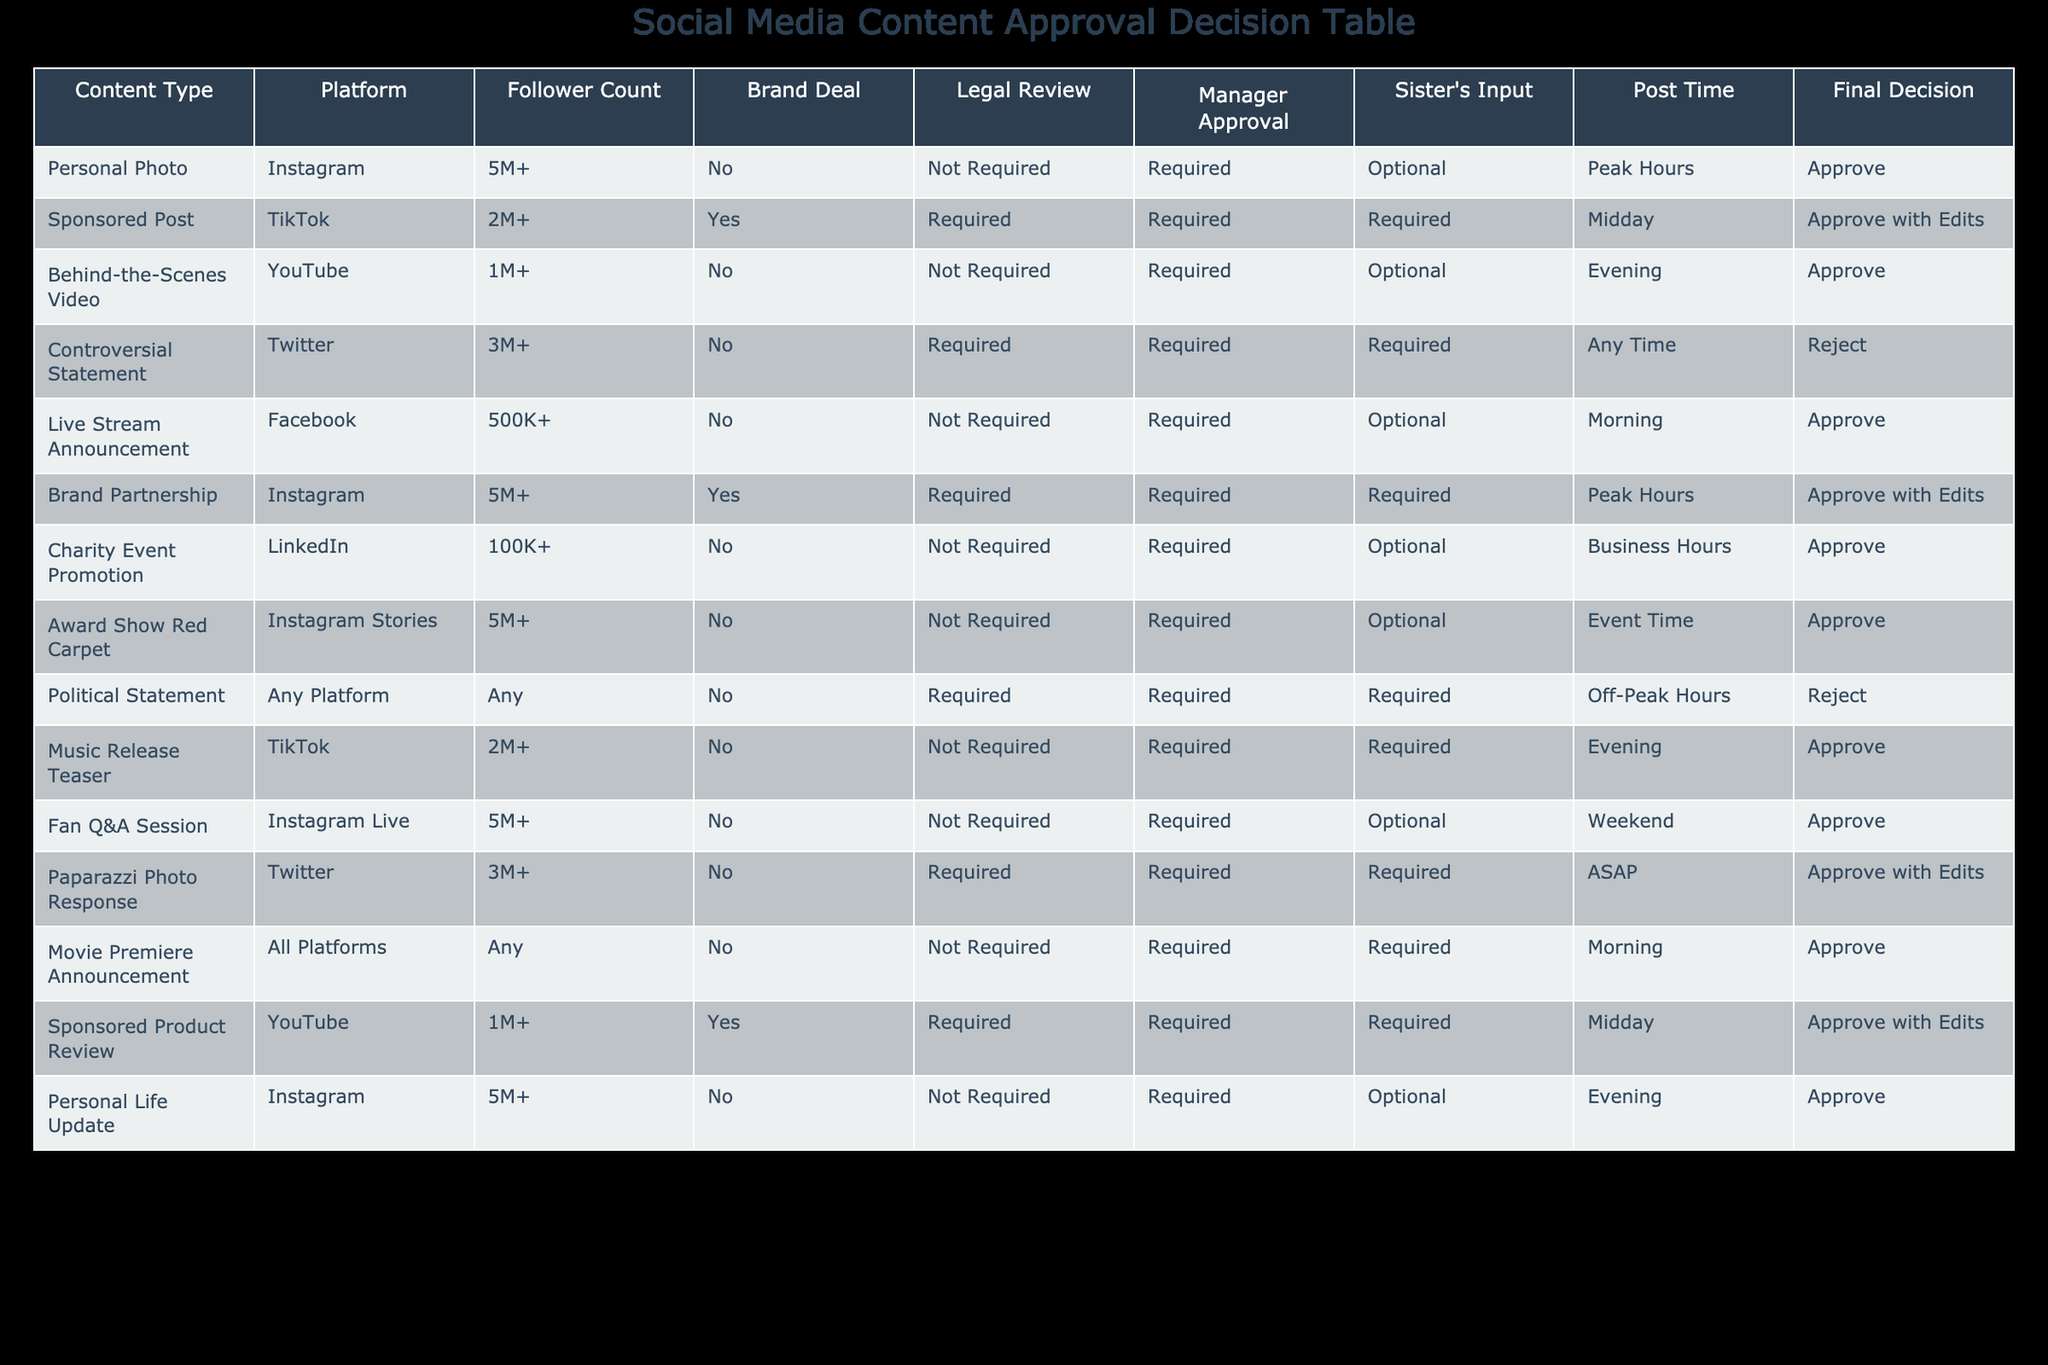What type of content requires legal review on TikTok? In the table, there are two entries for TikTok. The "Sponsored Post" has a "Legal Review" marked as "Required", while the "Music Release Teaser" does not require legal review. Thus, only the "Sponsored Post" requires legal review.
Answer: Sponsored Post How many content types received "Approve with Edits"? There are three entries with "Final Decision" listed as "Approve with Edits". They are "Sponsored Post", "Brand Partnership", and "Paparazzi Photo Response". So, the total is three.
Answer: 3 Is the "Charity Event Promotion" approved? The "Charity Event Promotion" entry shows a "Final Decision" of "Approve", meaning it was approved without any conditions.
Answer: Yes Which platform has the highest follower count for content requiring legal review? The table shows that the "Sponsored Product Review" on YouTube has a follower count of exactly "1M+". However, looking at the TikTok "Sponsored Post," it has "2M+" followers, making it the highest follower count for posts requiring legal review.
Answer: TikTok What percentage of the posts are approved without requests for edits or conditions? In the table, there are 12 types of content. Out of these, 6 received straightforward "Approve" decisions without edits or conditions: "Personal Photo," "Behind-the-Scenes Video," "Live Stream Announcement," "Award Show Red Carpet," "Fan Q&A Session," and "Personal Life Update." The percentage is (6/12) * 100 = 50%.
Answer: 50% How many rejected posts required both legal review and manager approval? In the table, the only post that was rejected is the "Controversial Statement," which required both "Legal Review" and "Manager Approval." Thus, only one post fits these criteria.
Answer: 1 Which type of content has the lowest follower count but still receives approval? The lowest follower count in the table is the "Charity Event Promotion" on LinkedIn with "100K+", and it received "Approve." So, this is the type of content that meets the criteria.
Answer: Charity Event Promotion How many social media platforms have content that was rejected? The table shows two types of content that were rejected: "Controversial Statement" on Twitter and "Political Statement" on any platform. Therefore, this amount indicates two separate platforms: Twitter and any platform.
Answer: 2 